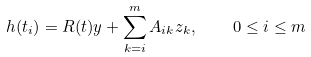<formula> <loc_0><loc_0><loc_500><loc_500>h ( t _ { i } ) = R ( t ) y + \sum _ { k = i } ^ { m } A _ { i k } z _ { k } , \quad 0 \leq i \leq m</formula> 